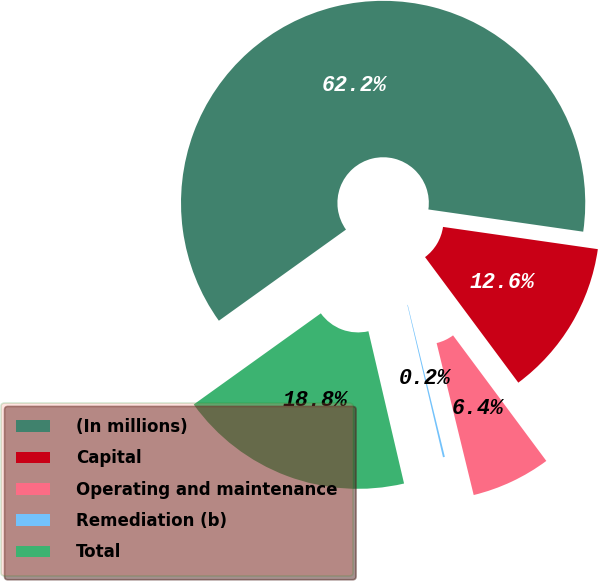<chart> <loc_0><loc_0><loc_500><loc_500><pie_chart><fcel>(In millions)<fcel>Capital<fcel>Operating and maintenance<fcel>Remediation (b)<fcel>Total<nl><fcel>62.17%<fcel>12.56%<fcel>6.36%<fcel>0.15%<fcel>18.76%<nl></chart> 